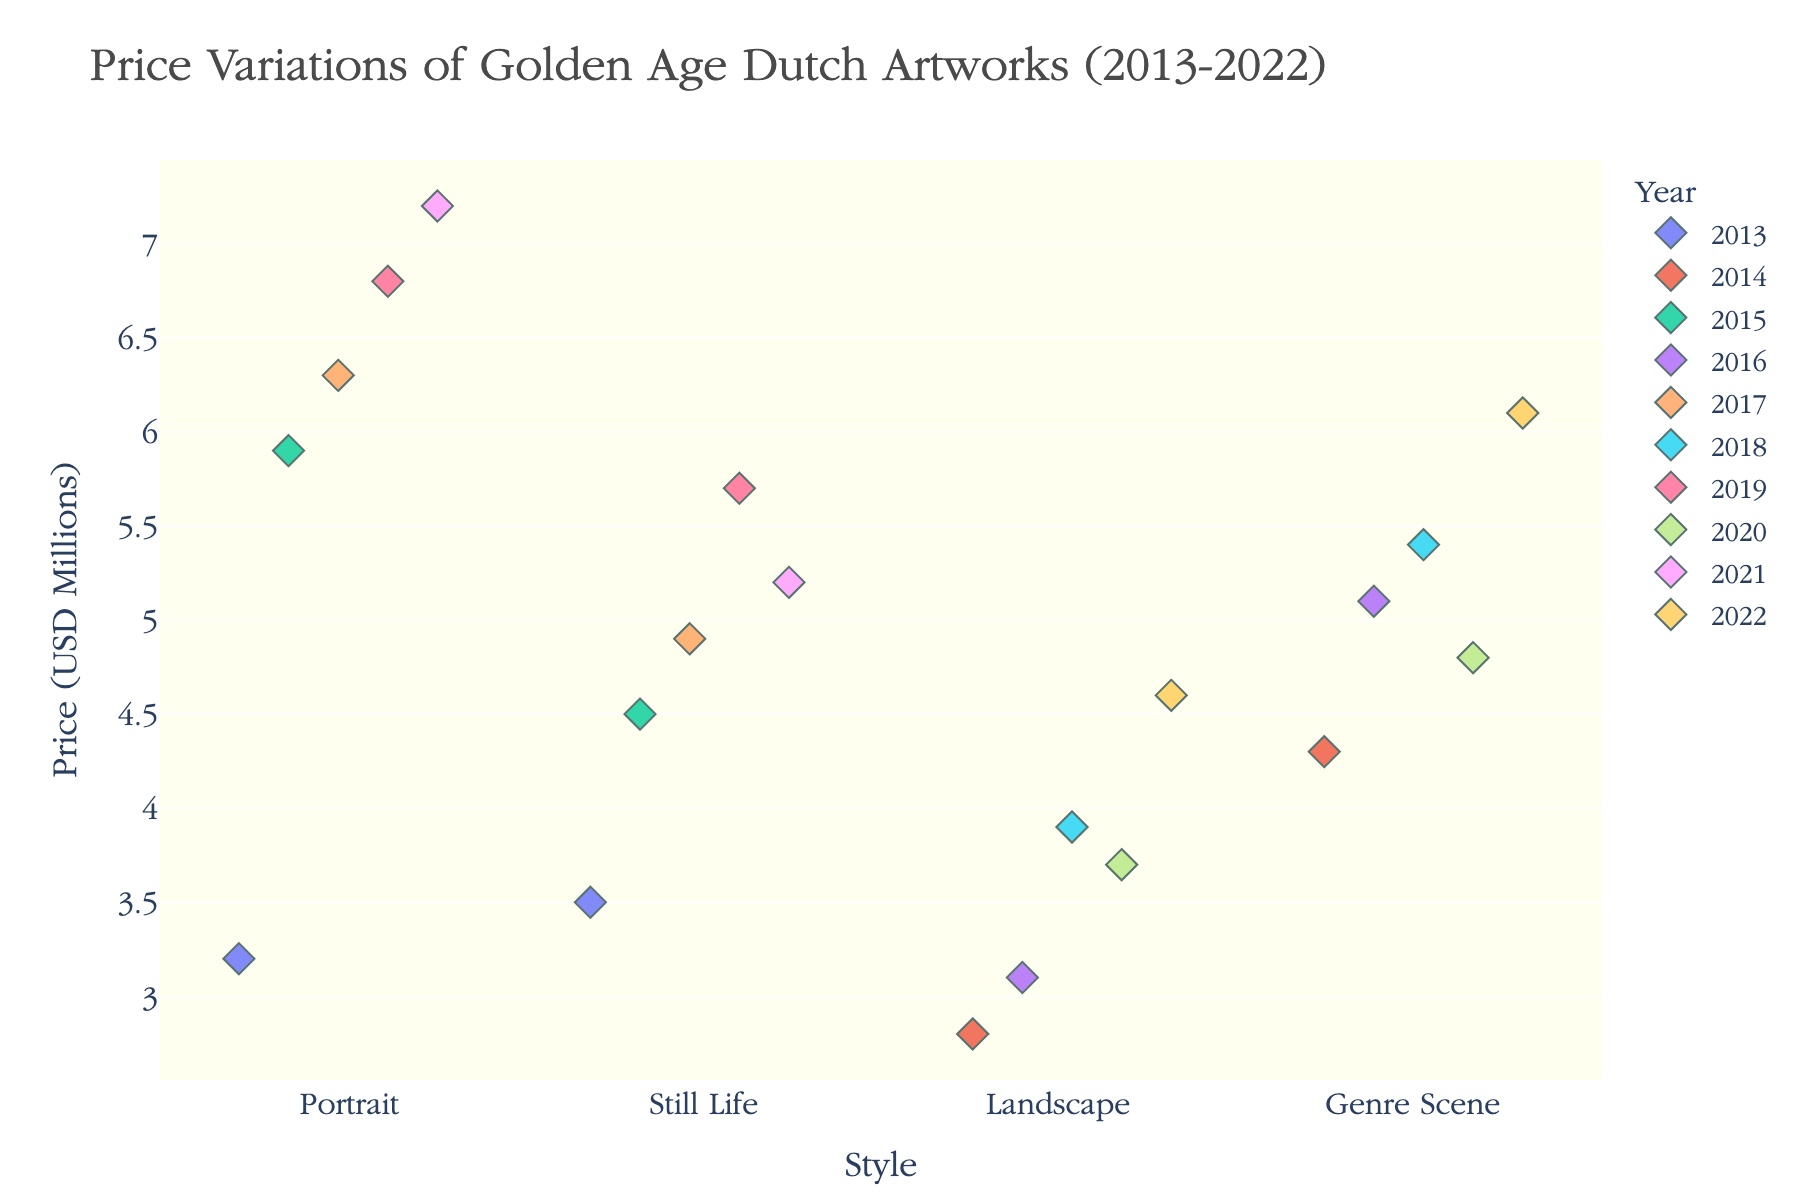what is the title of the plot? At the top of the plot, the string in larger font size indicates the title of the plot. It reads "Price Variations of Golden Age Dutch Artworks (2013-2022)".
Answer: Price Variations of Golden Age Dutch Artworks (2013-2022) what is the range of prices for Still Life paintings? By visually inspecting the y-axis for the "Still Life" category, the prices range from around 3.5 to 5.7 million USD.
Answer: 3.5 to 5.7 million USD which painting style has the highest average price? Calculate the average price for each painting style, then compare them. Portrait = (3.2+6.3+5.9+7.2+6.8)/5 = 5.88, Landscape = (2.8+3.9+3.1+3.7+4.6)/5 = 3.62, Still Life = (4.5+5.7+5.2+4.9+3.5)/5 = 4.76, Genre Scene = (5.1+4.8+6.1+5.4+4.3)/5 = 5.14, thus Portraits have the highest average price.
Answer: Portrait which year had the highest price for any painting? By examining the colored markers on the plot, the highest price for any painting is 7.2 million USD in the Portrait category for the year 2021 (noting color legend).
Answer: 2021 what is the median price for Landscape paintings? Sort Landscape prices: 2.8, 3.1, 3.7, 3.9, 4.6. The median is the middle value, which is the third value in the sorted list. Hence, the median price is 3.7 million USD.
Answer: 3.7 million USD compare the highest priced Portrait and Still Life paintings. which one is higher and by how much? The highest priced Portrait is 7.2 million USD, and the highest priced Still Life is 5.7 million USD. Subtract the Still Life price from the Portrait price: 7.2 - 5.7 = 1.5 million USD.
Answer: Portrait by 1.5 million USD which category shows the most variation in prices over the decade? Observe the spread of the data points for each category. Genre Scene displays the widest spread in the y-axis direction, showing the most variation from 4.3 to 6.1 million USD.
Answer: Genre Scene is there a trend in the price for Portrait paintings over the years? By analyzing the data points for Portraits in each year, there is a general upward trend from 3.2 in 2013 to 7.2 million USD in 2021, indicating increasing prices.
Answer: Upward trend 